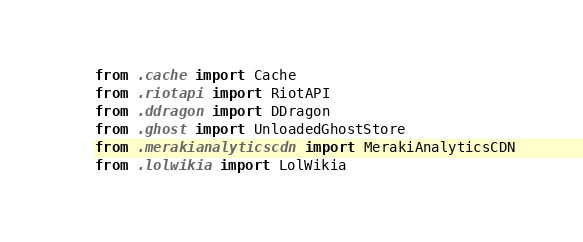<code> <loc_0><loc_0><loc_500><loc_500><_Python_>from .cache import Cache
from .riotapi import RiotAPI
from .ddragon import DDragon
from .ghost import UnloadedGhostStore
from .merakianalyticscdn import MerakiAnalyticsCDN
from .lolwikia import LolWikia
</code> 